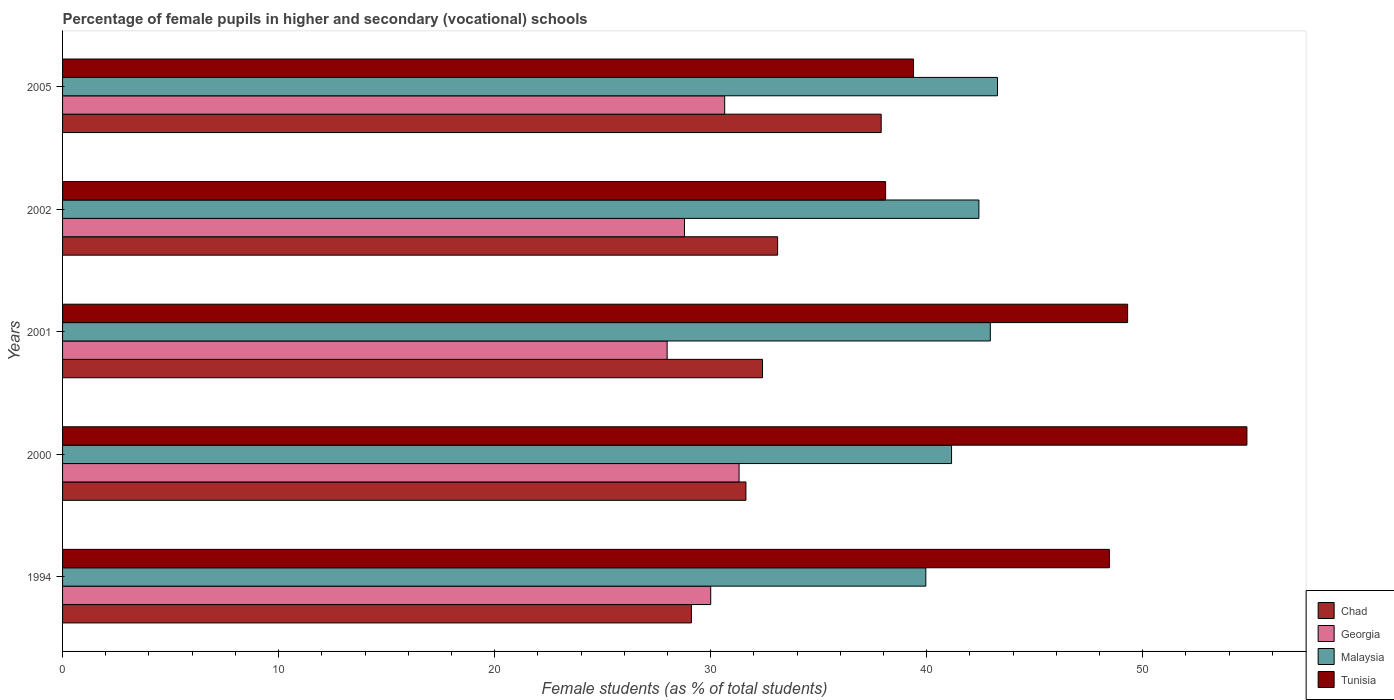How many groups of bars are there?
Make the answer very short. 5. Are the number of bars on each tick of the Y-axis equal?
Your answer should be very brief. Yes. What is the percentage of female pupils in higher and secondary schools in Georgia in 2001?
Offer a very short reply. 27.98. Across all years, what is the maximum percentage of female pupils in higher and secondary schools in Malaysia?
Ensure brevity in your answer.  43.28. Across all years, what is the minimum percentage of female pupils in higher and secondary schools in Georgia?
Provide a short and direct response. 27.98. In which year was the percentage of female pupils in higher and secondary schools in Malaysia maximum?
Offer a very short reply. 2005. What is the total percentage of female pupils in higher and secondary schools in Malaysia in the graph?
Your answer should be very brief. 209.74. What is the difference between the percentage of female pupils in higher and secondary schools in Chad in 2001 and that in 2002?
Keep it short and to the point. -0.7. What is the difference between the percentage of female pupils in higher and secondary schools in Chad in 2005 and the percentage of female pupils in higher and secondary schools in Georgia in 2001?
Provide a succinct answer. 9.91. What is the average percentage of female pupils in higher and secondary schools in Malaysia per year?
Your answer should be compact. 41.95. In the year 2002, what is the difference between the percentage of female pupils in higher and secondary schools in Georgia and percentage of female pupils in higher and secondary schools in Chad?
Offer a very short reply. -4.31. In how many years, is the percentage of female pupils in higher and secondary schools in Chad greater than 32 %?
Your answer should be very brief. 3. What is the ratio of the percentage of female pupils in higher and secondary schools in Malaysia in 1994 to that in 2002?
Offer a terse response. 0.94. What is the difference between the highest and the second highest percentage of female pupils in higher and secondary schools in Tunisia?
Your answer should be compact. 5.52. What is the difference between the highest and the lowest percentage of female pupils in higher and secondary schools in Georgia?
Provide a short and direct response. 3.33. In how many years, is the percentage of female pupils in higher and secondary schools in Malaysia greater than the average percentage of female pupils in higher and secondary schools in Malaysia taken over all years?
Your response must be concise. 3. What does the 1st bar from the top in 2000 represents?
Offer a terse response. Tunisia. What does the 3rd bar from the bottom in 2002 represents?
Your answer should be compact. Malaysia. Is it the case that in every year, the sum of the percentage of female pupils in higher and secondary schools in Chad and percentage of female pupils in higher and secondary schools in Tunisia is greater than the percentage of female pupils in higher and secondary schools in Malaysia?
Your answer should be very brief. Yes. How many bars are there?
Provide a short and direct response. 20. How many years are there in the graph?
Ensure brevity in your answer.  5. Where does the legend appear in the graph?
Make the answer very short. Bottom right. How many legend labels are there?
Ensure brevity in your answer.  4. What is the title of the graph?
Give a very brief answer. Percentage of female pupils in higher and secondary (vocational) schools. Does "Sub-Saharan Africa (developing only)" appear as one of the legend labels in the graph?
Provide a succinct answer. No. What is the label or title of the X-axis?
Ensure brevity in your answer.  Female students (as % of total students). What is the Female students (as % of total students) in Chad in 1994?
Offer a very short reply. 29.11. What is the Female students (as % of total students) of Georgia in 1994?
Your answer should be very brief. 30. What is the Female students (as % of total students) of Malaysia in 1994?
Your answer should be compact. 39.96. What is the Female students (as % of total students) of Tunisia in 1994?
Provide a succinct answer. 48.45. What is the Female students (as % of total students) in Chad in 2000?
Your answer should be very brief. 31.63. What is the Female students (as % of total students) in Georgia in 2000?
Your answer should be compact. 31.31. What is the Female students (as % of total students) in Malaysia in 2000?
Make the answer very short. 41.15. What is the Female students (as % of total students) of Tunisia in 2000?
Your response must be concise. 54.82. What is the Female students (as % of total students) in Chad in 2001?
Ensure brevity in your answer.  32.4. What is the Female students (as % of total students) in Georgia in 2001?
Your answer should be compact. 27.98. What is the Female students (as % of total students) of Malaysia in 2001?
Offer a very short reply. 42.94. What is the Female students (as % of total students) of Tunisia in 2001?
Provide a short and direct response. 49.3. What is the Female students (as % of total students) in Chad in 2002?
Keep it short and to the point. 33.1. What is the Female students (as % of total students) in Georgia in 2002?
Your answer should be compact. 28.79. What is the Female students (as % of total students) in Malaysia in 2002?
Give a very brief answer. 42.42. What is the Female students (as % of total students) in Tunisia in 2002?
Give a very brief answer. 38.1. What is the Female students (as % of total students) of Chad in 2005?
Provide a short and direct response. 37.89. What is the Female students (as % of total students) of Georgia in 2005?
Offer a very short reply. 30.65. What is the Female students (as % of total students) of Malaysia in 2005?
Your answer should be compact. 43.28. What is the Female students (as % of total students) in Tunisia in 2005?
Your answer should be compact. 39.39. Across all years, what is the maximum Female students (as % of total students) in Chad?
Your answer should be very brief. 37.89. Across all years, what is the maximum Female students (as % of total students) in Georgia?
Provide a short and direct response. 31.31. Across all years, what is the maximum Female students (as % of total students) of Malaysia?
Provide a short and direct response. 43.28. Across all years, what is the maximum Female students (as % of total students) of Tunisia?
Keep it short and to the point. 54.82. Across all years, what is the minimum Female students (as % of total students) of Chad?
Keep it short and to the point. 29.11. Across all years, what is the minimum Female students (as % of total students) in Georgia?
Keep it short and to the point. 27.98. Across all years, what is the minimum Female students (as % of total students) in Malaysia?
Provide a succinct answer. 39.96. Across all years, what is the minimum Female students (as % of total students) of Tunisia?
Ensure brevity in your answer.  38.1. What is the total Female students (as % of total students) in Chad in the graph?
Provide a succinct answer. 164.13. What is the total Female students (as % of total students) of Georgia in the graph?
Your response must be concise. 148.74. What is the total Female students (as % of total students) in Malaysia in the graph?
Your response must be concise. 209.74. What is the total Female students (as % of total students) of Tunisia in the graph?
Offer a terse response. 230.06. What is the difference between the Female students (as % of total students) in Chad in 1994 and that in 2000?
Make the answer very short. -2.52. What is the difference between the Female students (as % of total students) in Georgia in 1994 and that in 2000?
Offer a very short reply. -1.31. What is the difference between the Female students (as % of total students) in Malaysia in 1994 and that in 2000?
Keep it short and to the point. -1.19. What is the difference between the Female students (as % of total students) in Tunisia in 1994 and that in 2000?
Provide a short and direct response. -6.37. What is the difference between the Female students (as % of total students) of Chad in 1994 and that in 2001?
Keep it short and to the point. -3.29. What is the difference between the Female students (as % of total students) in Georgia in 1994 and that in 2001?
Make the answer very short. 2.02. What is the difference between the Female students (as % of total students) of Malaysia in 1994 and that in 2001?
Your answer should be very brief. -2.99. What is the difference between the Female students (as % of total students) in Tunisia in 1994 and that in 2001?
Keep it short and to the point. -0.85. What is the difference between the Female students (as % of total students) of Chad in 1994 and that in 2002?
Your response must be concise. -3.99. What is the difference between the Female students (as % of total students) in Georgia in 1994 and that in 2002?
Ensure brevity in your answer.  1.22. What is the difference between the Female students (as % of total students) of Malaysia in 1994 and that in 2002?
Provide a short and direct response. -2.46. What is the difference between the Female students (as % of total students) in Tunisia in 1994 and that in 2002?
Your answer should be very brief. 10.36. What is the difference between the Female students (as % of total students) in Chad in 1994 and that in 2005?
Your response must be concise. -8.78. What is the difference between the Female students (as % of total students) in Georgia in 1994 and that in 2005?
Offer a terse response. -0.65. What is the difference between the Female students (as % of total students) of Malaysia in 1994 and that in 2005?
Keep it short and to the point. -3.32. What is the difference between the Female students (as % of total students) in Tunisia in 1994 and that in 2005?
Your answer should be very brief. 9.06. What is the difference between the Female students (as % of total students) in Chad in 2000 and that in 2001?
Give a very brief answer. -0.77. What is the difference between the Female students (as % of total students) of Georgia in 2000 and that in 2001?
Offer a terse response. 3.33. What is the difference between the Female students (as % of total students) in Malaysia in 2000 and that in 2001?
Keep it short and to the point. -1.79. What is the difference between the Female students (as % of total students) in Tunisia in 2000 and that in 2001?
Your response must be concise. 5.52. What is the difference between the Female students (as % of total students) of Chad in 2000 and that in 2002?
Provide a short and direct response. -1.47. What is the difference between the Female students (as % of total students) of Georgia in 2000 and that in 2002?
Offer a very short reply. 2.53. What is the difference between the Female students (as % of total students) of Malaysia in 2000 and that in 2002?
Your response must be concise. -1.27. What is the difference between the Female students (as % of total students) of Tunisia in 2000 and that in 2002?
Give a very brief answer. 16.72. What is the difference between the Female students (as % of total students) of Chad in 2000 and that in 2005?
Offer a very short reply. -6.26. What is the difference between the Female students (as % of total students) in Georgia in 2000 and that in 2005?
Give a very brief answer. 0.67. What is the difference between the Female students (as % of total students) in Malaysia in 2000 and that in 2005?
Ensure brevity in your answer.  -2.13. What is the difference between the Female students (as % of total students) of Tunisia in 2000 and that in 2005?
Offer a terse response. 15.43. What is the difference between the Female students (as % of total students) in Chad in 2001 and that in 2002?
Offer a terse response. -0.7. What is the difference between the Female students (as % of total students) in Georgia in 2001 and that in 2002?
Make the answer very short. -0.8. What is the difference between the Female students (as % of total students) in Malaysia in 2001 and that in 2002?
Ensure brevity in your answer.  0.53. What is the difference between the Female students (as % of total students) in Tunisia in 2001 and that in 2002?
Ensure brevity in your answer.  11.2. What is the difference between the Female students (as % of total students) in Chad in 2001 and that in 2005?
Keep it short and to the point. -5.49. What is the difference between the Female students (as % of total students) of Georgia in 2001 and that in 2005?
Your response must be concise. -2.66. What is the difference between the Female students (as % of total students) in Malaysia in 2001 and that in 2005?
Your response must be concise. -0.33. What is the difference between the Female students (as % of total students) in Tunisia in 2001 and that in 2005?
Make the answer very short. 9.91. What is the difference between the Female students (as % of total students) in Chad in 2002 and that in 2005?
Provide a short and direct response. -4.79. What is the difference between the Female students (as % of total students) in Georgia in 2002 and that in 2005?
Your answer should be compact. -1.86. What is the difference between the Female students (as % of total students) in Malaysia in 2002 and that in 2005?
Provide a short and direct response. -0.86. What is the difference between the Female students (as % of total students) of Tunisia in 2002 and that in 2005?
Keep it short and to the point. -1.29. What is the difference between the Female students (as % of total students) in Chad in 1994 and the Female students (as % of total students) in Georgia in 2000?
Make the answer very short. -2.21. What is the difference between the Female students (as % of total students) in Chad in 1994 and the Female students (as % of total students) in Malaysia in 2000?
Ensure brevity in your answer.  -12.04. What is the difference between the Female students (as % of total students) of Chad in 1994 and the Female students (as % of total students) of Tunisia in 2000?
Make the answer very short. -25.71. What is the difference between the Female students (as % of total students) in Georgia in 1994 and the Female students (as % of total students) in Malaysia in 2000?
Ensure brevity in your answer.  -11.15. What is the difference between the Female students (as % of total students) in Georgia in 1994 and the Female students (as % of total students) in Tunisia in 2000?
Your answer should be very brief. -24.82. What is the difference between the Female students (as % of total students) in Malaysia in 1994 and the Female students (as % of total students) in Tunisia in 2000?
Ensure brevity in your answer.  -14.86. What is the difference between the Female students (as % of total students) in Chad in 1994 and the Female students (as % of total students) in Georgia in 2001?
Offer a terse response. 1.12. What is the difference between the Female students (as % of total students) in Chad in 1994 and the Female students (as % of total students) in Malaysia in 2001?
Make the answer very short. -13.83. What is the difference between the Female students (as % of total students) in Chad in 1994 and the Female students (as % of total students) in Tunisia in 2001?
Your response must be concise. -20.19. What is the difference between the Female students (as % of total students) of Georgia in 1994 and the Female students (as % of total students) of Malaysia in 2001?
Your answer should be compact. -12.94. What is the difference between the Female students (as % of total students) of Georgia in 1994 and the Female students (as % of total students) of Tunisia in 2001?
Offer a very short reply. -19.3. What is the difference between the Female students (as % of total students) of Malaysia in 1994 and the Female students (as % of total students) of Tunisia in 2001?
Give a very brief answer. -9.34. What is the difference between the Female students (as % of total students) of Chad in 1994 and the Female students (as % of total students) of Georgia in 2002?
Offer a very short reply. 0.32. What is the difference between the Female students (as % of total students) in Chad in 1994 and the Female students (as % of total students) in Malaysia in 2002?
Make the answer very short. -13.31. What is the difference between the Female students (as % of total students) of Chad in 1994 and the Female students (as % of total students) of Tunisia in 2002?
Offer a very short reply. -8.99. What is the difference between the Female students (as % of total students) in Georgia in 1994 and the Female students (as % of total students) in Malaysia in 2002?
Offer a terse response. -12.41. What is the difference between the Female students (as % of total students) of Georgia in 1994 and the Female students (as % of total students) of Tunisia in 2002?
Keep it short and to the point. -8.1. What is the difference between the Female students (as % of total students) of Malaysia in 1994 and the Female students (as % of total students) of Tunisia in 2002?
Make the answer very short. 1.86. What is the difference between the Female students (as % of total students) of Chad in 1994 and the Female students (as % of total students) of Georgia in 2005?
Make the answer very short. -1.54. What is the difference between the Female students (as % of total students) in Chad in 1994 and the Female students (as % of total students) in Malaysia in 2005?
Make the answer very short. -14.17. What is the difference between the Female students (as % of total students) in Chad in 1994 and the Female students (as % of total students) in Tunisia in 2005?
Provide a short and direct response. -10.28. What is the difference between the Female students (as % of total students) of Georgia in 1994 and the Female students (as % of total students) of Malaysia in 2005?
Keep it short and to the point. -13.27. What is the difference between the Female students (as % of total students) of Georgia in 1994 and the Female students (as % of total students) of Tunisia in 2005?
Offer a terse response. -9.39. What is the difference between the Female students (as % of total students) in Malaysia in 1994 and the Female students (as % of total students) in Tunisia in 2005?
Offer a terse response. 0.57. What is the difference between the Female students (as % of total students) of Chad in 2000 and the Female students (as % of total students) of Georgia in 2001?
Provide a succinct answer. 3.65. What is the difference between the Female students (as % of total students) in Chad in 2000 and the Female students (as % of total students) in Malaysia in 2001?
Give a very brief answer. -11.31. What is the difference between the Female students (as % of total students) of Chad in 2000 and the Female students (as % of total students) of Tunisia in 2001?
Ensure brevity in your answer.  -17.67. What is the difference between the Female students (as % of total students) of Georgia in 2000 and the Female students (as % of total students) of Malaysia in 2001?
Make the answer very short. -11.63. What is the difference between the Female students (as % of total students) in Georgia in 2000 and the Female students (as % of total students) in Tunisia in 2001?
Keep it short and to the point. -17.98. What is the difference between the Female students (as % of total students) of Malaysia in 2000 and the Female students (as % of total students) of Tunisia in 2001?
Provide a succinct answer. -8.15. What is the difference between the Female students (as % of total students) of Chad in 2000 and the Female students (as % of total students) of Georgia in 2002?
Give a very brief answer. 2.84. What is the difference between the Female students (as % of total students) in Chad in 2000 and the Female students (as % of total students) in Malaysia in 2002?
Provide a short and direct response. -10.78. What is the difference between the Female students (as % of total students) of Chad in 2000 and the Female students (as % of total students) of Tunisia in 2002?
Provide a short and direct response. -6.47. What is the difference between the Female students (as % of total students) of Georgia in 2000 and the Female students (as % of total students) of Malaysia in 2002?
Your answer should be very brief. -11.1. What is the difference between the Female students (as % of total students) of Georgia in 2000 and the Female students (as % of total students) of Tunisia in 2002?
Ensure brevity in your answer.  -6.78. What is the difference between the Female students (as % of total students) of Malaysia in 2000 and the Female students (as % of total students) of Tunisia in 2002?
Offer a very short reply. 3.05. What is the difference between the Female students (as % of total students) of Chad in 2000 and the Female students (as % of total students) of Georgia in 2005?
Provide a succinct answer. 0.98. What is the difference between the Female students (as % of total students) of Chad in 2000 and the Female students (as % of total students) of Malaysia in 2005?
Your response must be concise. -11.65. What is the difference between the Female students (as % of total students) in Chad in 2000 and the Female students (as % of total students) in Tunisia in 2005?
Give a very brief answer. -7.76. What is the difference between the Female students (as % of total students) in Georgia in 2000 and the Female students (as % of total students) in Malaysia in 2005?
Your response must be concise. -11.96. What is the difference between the Female students (as % of total students) in Georgia in 2000 and the Female students (as % of total students) in Tunisia in 2005?
Keep it short and to the point. -8.08. What is the difference between the Female students (as % of total students) in Malaysia in 2000 and the Female students (as % of total students) in Tunisia in 2005?
Offer a terse response. 1.76. What is the difference between the Female students (as % of total students) in Chad in 2001 and the Female students (as % of total students) in Georgia in 2002?
Your response must be concise. 3.61. What is the difference between the Female students (as % of total students) of Chad in 2001 and the Female students (as % of total students) of Malaysia in 2002?
Offer a very short reply. -10.02. What is the difference between the Female students (as % of total students) of Chad in 2001 and the Female students (as % of total students) of Tunisia in 2002?
Your response must be concise. -5.7. What is the difference between the Female students (as % of total students) in Georgia in 2001 and the Female students (as % of total students) in Malaysia in 2002?
Your answer should be compact. -14.43. What is the difference between the Female students (as % of total students) of Georgia in 2001 and the Female students (as % of total students) of Tunisia in 2002?
Offer a terse response. -10.11. What is the difference between the Female students (as % of total students) of Malaysia in 2001 and the Female students (as % of total students) of Tunisia in 2002?
Your response must be concise. 4.85. What is the difference between the Female students (as % of total students) in Chad in 2001 and the Female students (as % of total students) in Georgia in 2005?
Make the answer very short. 1.75. What is the difference between the Female students (as % of total students) of Chad in 2001 and the Female students (as % of total students) of Malaysia in 2005?
Keep it short and to the point. -10.88. What is the difference between the Female students (as % of total students) in Chad in 2001 and the Female students (as % of total students) in Tunisia in 2005?
Ensure brevity in your answer.  -6.99. What is the difference between the Female students (as % of total students) of Georgia in 2001 and the Female students (as % of total students) of Malaysia in 2005?
Give a very brief answer. -15.29. What is the difference between the Female students (as % of total students) of Georgia in 2001 and the Female students (as % of total students) of Tunisia in 2005?
Provide a succinct answer. -11.41. What is the difference between the Female students (as % of total students) in Malaysia in 2001 and the Female students (as % of total students) in Tunisia in 2005?
Your answer should be compact. 3.55. What is the difference between the Female students (as % of total students) in Chad in 2002 and the Female students (as % of total students) in Georgia in 2005?
Provide a short and direct response. 2.45. What is the difference between the Female students (as % of total students) in Chad in 2002 and the Female students (as % of total students) in Malaysia in 2005?
Make the answer very short. -10.18. What is the difference between the Female students (as % of total students) in Chad in 2002 and the Female students (as % of total students) in Tunisia in 2005?
Your response must be concise. -6.29. What is the difference between the Female students (as % of total students) in Georgia in 2002 and the Female students (as % of total students) in Malaysia in 2005?
Give a very brief answer. -14.49. What is the difference between the Female students (as % of total students) in Georgia in 2002 and the Female students (as % of total students) in Tunisia in 2005?
Ensure brevity in your answer.  -10.6. What is the difference between the Female students (as % of total students) of Malaysia in 2002 and the Female students (as % of total students) of Tunisia in 2005?
Make the answer very short. 3.03. What is the average Female students (as % of total students) of Chad per year?
Give a very brief answer. 32.83. What is the average Female students (as % of total students) in Georgia per year?
Ensure brevity in your answer.  29.75. What is the average Female students (as % of total students) of Malaysia per year?
Provide a succinct answer. 41.95. What is the average Female students (as % of total students) of Tunisia per year?
Give a very brief answer. 46.01. In the year 1994, what is the difference between the Female students (as % of total students) in Chad and Female students (as % of total students) in Georgia?
Your response must be concise. -0.89. In the year 1994, what is the difference between the Female students (as % of total students) in Chad and Female students (as % of total students) in Malaysia?
Keep it short and to the point. -10.85. In the year 1994, what is the difference between the Female students (as % of total students) of Chad and Female students (as % of total students) of Tunisia?
Provide a short and direct response. -19.35. In the year 1994, what is the difference between the Female students (as % of total students) of Georgia and Female students (as % of total students) of Malaysia?
Your response must be concise. -9.96. In the year 1994, what is the difference between the Female students (as % of total students) in Georgia and Female students (as % of total students) in Tunisia?
Make the answer very short. -18.45. In the year 1994, what is the difference between the Female students (as % of total students) in Malaysia and Female students (as % of total students) in Tunisia?
Provide a short and direct response. -8.5. In the year 2000, what is the difference between the Female students (as % of total students) in Chad and Female students (as % of total students) in Georgia?
Your response must be concise. 0.32. In the year 2000, what is the difference between the Female students (as % of total students) in Chad and Female students (as % of total students) in Malaysia?
Provide a succinct answer. -9.52. In the year 2000, what is the difference between the Female students (as % of total students) of Chad and Female students (as % of total students) of Tunisia?
Your answer should be very brief. -23.19. In the year 2000, what is the difference between the Female students (as % of total students) in Georgia and Female students (as % of total students) in Malaysia?
Your answer should be very brief. -9.84. In the year 2000, what is the difference between the Female students (as % of total students) in Georgia and Female students (as % of total students) in Tunisia?
Offer a terse response. -23.51. In the year 2000, what is the difference between the Female students (as % of total students) of Malaysia and Female students (as % of total students) of Tunisia?
Offer a terse response. -13.67. In the year 2001, what is the difference between the Female students (as % of total students) of Chad and Female students (as % of total students) of Georgia?
Your answer should be compact. 4.42. In the year 2001, what is the difference between the Female students (as % of total students) in Chad and Female students (as % of total students) in Malaysia?
Give a very brief answer. -10.54. In the year 2001, what is the difference between the Female students (as % of total students) of Chad and Female students (as % of total students) of Tunisia?
Offer a very short reply. -16.9. In the year 2001, what is the difference between the Female students (as % of total students) of Georgia and Female students (as % of total students) of Malaysia?
Ensure brevity in your answer.  -14.96. In the year 2001, what is the difference between the Female students (as % of total students) in Georgia and Female students (as % of total students) in Tunisia?
Your response must be concise. -21.31. In the year 2001, what is the difference between the Female students (as % of total students) of Malaysia and Female students (as % of total students) of Tunisia?
Provide a succinct answer. -6.36. In the year 2002, what is the difference between the Female students (as % of total students) in Chad and Female students (as % of total students) in Georgia?
Offer a very short reply. 4.31. In the year 2002, what is the difference between the Female students (as % of total students) of Chad and Female students (as % of total students) of Malaysia?
Offer a terse response. -9.32. In the year 2002, what is the difference between the Female students (as % of total students) of Chad and Female students (as % of total students) of Tunisia?
Provide a succinct answer. -5. In the year 2002, what is the difference between the Female students (as % of total students) of Georgia and Female students (as % of total students) of Malaysia?
Offer a terse response. -13.63. In the year 2002, what is the difference between the Female students (as % of total students) of Georgia and Female students (as % of total students) of Tunisia?
Provide a short and direct response. -9.31. In the year 2002, what is the difference between the Female students (as % of total students) in Malaysia and Female students (as % of total students) in Tunisia?
Ensure brevity in your answer.  4.32. In the year 2005, what is the difference between the Female students (as % of total students) in Chad and Female students (as % of total students) in Georgia?
Give a very brief answer. 7.24. In the year 2005, what is the difference between the Female students (as % of total students) in Chad and Female students (as % of total students) in Malaysia?
Ensure brevity in your answer.  -5.38. In the year 2005, what is the difference between the Female students (as % of total students) in Chad and Female students (as % of total students) in Tunisia?
Offer a very short reply. -1.5. In the year 2005, what is the difference between the Female students (as % of total students) of Georgia and Female students (as % of total students) of Malaysia?
Provide a succinct answer. -12.63. In the year 2005, what is the difference between the Female students (as % of total students) of Georgia and Female students (as % of total students) of Tunisia?
Ensure brevity in your answer.  -8.74. In the year 2005, what is the difference between the Female students (as % of total students) of Malaysia and Female students (as % of total students) of Tunisia?
Offer a terse response. 3.89. What is the ratio of the Female students (as % of total students) of Chad in 1994 to that in 2000?
Make the answer very short. 0.92. What is the ratio of the Female students (as % of total students) in Georgia in 1994 to that in 2000?
Provide a succinct answer. 0.96. What is the ratio of the Female students (as % of total students) in Malaysia in 1994 to that in 2000?
Ensure brevity in your answer.  0.97. What is the ratio of the Female students (as % of total students) in Tunisia in 1994 to that in 2000?
Your answer should be compact. 0.88. What is the ratio of the Female students (as % of total students) of Chad in 1994 to that in 2001?
Your answer should be very brief. 0.9. What is the ratio of the Female students (as % of total students) of Georgia in 1994 to that in 2001?
Your answer should be compact. 1.07. What is the ratio of the Female students (as % of total students) of Malaysia in 1994 to that in 2001?
Make the answer very short. 0.93. What is the ratio of the Female students (as % of total students) in Tunisia in 1994 to that in 2001?
Keep it short and to the point. 0.98. What is the ratio of the Female students (as % of total students) of Chad in 1994 to that in 2002?
Your answer should be very brief. 0.88. What is the ratio of the Female students (as % of total students) of Georgia in 1994 to that in 2002?
Ensure brevity in your answer.  1.04. What is the ratio of the Female students (as % of total students) in Malaysia in 1994 to that in 2002?
Provide a succinct answer. 0.94. What is the ratio of the Female students (as % of total students) in Tunisia in 1994 to that in 2002?
Ensure brevity in your answer.  1.27. What is the ratio of the Female students (as % of total students) in Chad in 1994 to that in 2005?
Offer a very short reply. 0.77. What is the ratio of the Female students (as % of total students) in Georgia in 1994 to that in 2005?
Make the answer very short. 0.98. What is the ratio of the Female students (as % of total students) in Malaysia in 1994 to that in 2005?
Your answer should be compact. 0.92. What is the ratio of the Female students (as % of total students) in Tunisia in 1994 to that in 2005?
Offer a very short reply. 1.23. What is the ratio of the Female students (as % of total students) of Chad in 2000 to that in 2001?
Ensure brevity in your answer.  0.98. What is the ratio of the Female students (as % of total students) in Georgia in 2000 to that in 2001?
Ensure brevity in your answer.  1.12. What is the ratio of the Female students (as % of total students) of Malaysia in 2000 to that in 2001?
Your answer should be compact. 0.96. What is the ratio of the Female students (as % of total students) of Tunisia in 2000 to that in 2001?
Provide a short and direct response. 1.11. What is the ratio of the Female students (as % of total students) in Chad in 2000 to that in 2002?
Your response must be concise. 0.96. What is the ratio of the Female students (as % of total students) of Georgia in 2000 to that in 2002?
Ensure brevity in your answer.  1.09. What is the ratio of the Female students (as % of total students) of Malaysia in 2000 to that in 2002?
Your answer should be compact. 0.97. What is the ratio of the Female students (as % of total students) in Tunisia in 2000 to that in 2002?
Offer a very short reply. 1.44. What is the ratio of the Female students (as % of total students) in Chad in 2000 to that in 2005?
Give a very brief answer. 0.83. What is the ratio of the Female students (as % of total students) of Georgia in 2000 to that in 2005?
Your answer should be compact. 1.02. What is the ratio of the Female students (as % of total students) of Malaysia in 2000 to that in 2005?
Give a very brief answer. 0.95. What is the ratio of the Female students (as % of total students) of Tunisia in 2000 to that in 2005?
Give a very brief answer. 1.39. What is the ratio of the Female students (as % of total students) in Chad in 2001 to that in 2002?
Your answer should be compact. 0.98. What is the ratio of the Female students (as % of total students) of Georgia in 2001 to that in 2002?
Your answer should be very brief. 0.97. What is the ratio of the Female students (as % of total students) in Malaysia in 2001 to that in 2002?
Your answer should be very brief. 1.01. What is the ratio of the Female students (as % of total students) in Tunisia in 2001 to that in 2002?
Give a very brief answer. 1.29. What is the ratio of the Female students (as % of total students) of Chad in 2001 to that in 2005?
Offer a very short reply. 0.86. What is the ratio of the Female students (as % of total students) of Georgia in 2001 to that in 2005?
Offer a very short reply. 0.91. What is the ratio of the Female students (as % of total students) in Tunisia in 2001 to that in 2005?
Your answer should be very brief. 1.25. What is the ratio of the Female students (as % of total students) of Chad in 2002 to that in 2005?
Your response must be concise. 0.87. What is the ratio of the Female students (as % of total students) of Georgia in 2002 to that in 2005?
Offer a terse response. 0.94. What is the ratio of the Female students (as % of total students) of Malaysia in 2002 to that in 2005?
Provide a succinct answer. 0.98. What is the ratio of the Female students (as % of total students) in Tunisia in 2002 to that in 2005?
Provide a short and direct response. 0.97. What is the difference between the highest and the second highest Female students (as % of total students) in Chad?
Give a very brief answer. 4.79. What is the difference between the highest and the second highest Female students (as % of total students) of Georgia?
Provide a succinct answer. 0.67. What is the difference between the highest and the second highest Female students (as % of total students) in Malaysia?
Your answer should be compact. 0.33. What is the difference between the highest and the second highest Female students (as % of total students) of Tunisia?
Your answer should be compact. 5.52. What is the difference between the highest and the lowest Female students (as % of total students) in Chad?
Make the answer very short. 8.78. What is the difference between the highest and the lowest Female students (as % of total students) of Georgia?
Make the answer very short. 3.33. What is the difference between the highest and the lowest Female students (as % of total students) of Malaysia?
Offer a very short reply. 3.32. What is the difference between the highest and the lowest Female students (as % of total students) in Tunisia?
Offer a terse response. 16.72. 